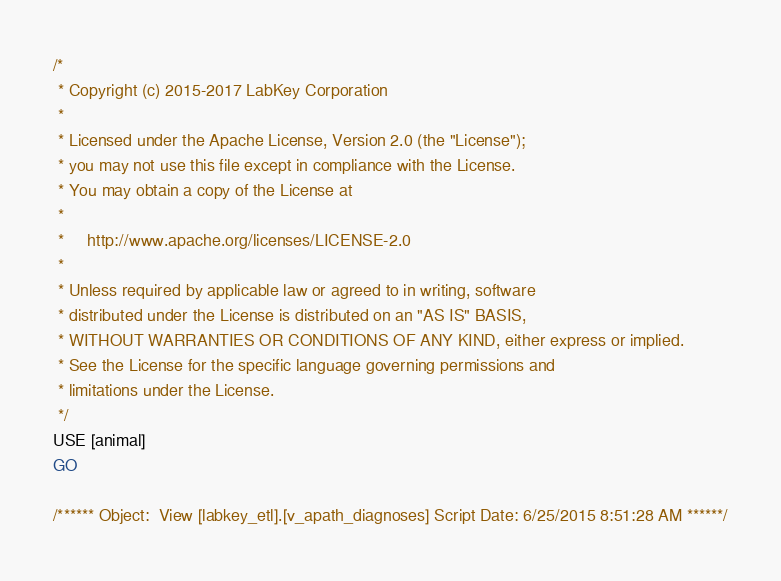<code> <loc_0><loc_0><loc_500><loc_500><_SQL_>/*
 * Copyright (c) 2015-2017 LabKey Corporation
 *
 * Licensed under the Apache License, Version 2.0 (the "License");
 * you may not use this file except in compliance with the License.
 * You may obtain a copy of the License at
 *
 *     http://www.apache.org/licenses/LICENSE-2.0
 *
 * Unless required by applicable law or agreed to in writing, software
 * distributed under the License is distributed on an "AS IS" BASIS,
 * WITHOUT WARRANTIES OR CONDITIONS OF ANY KIND, either express or implied.
 * See the License for the specific language governing permissions and
 * limitations under the License.
 */
USE [animal]
GO

/****** Object:  View [labkey_etl].[v_apath_diagnoses] Script Date: 6/25/2015 8:51:28 AM ******/</code> 